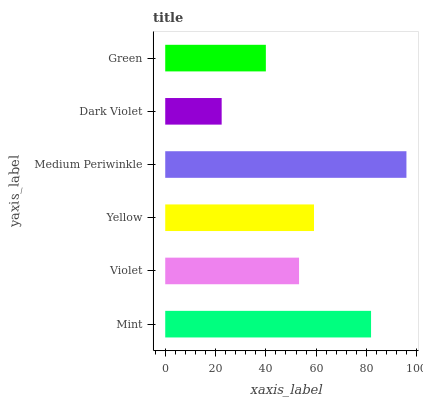Is Dark Violet the minimum?
Answer yes or no. Yes. Is Medium Periwinkle the maximum?
Answer yes or no. Yes. Is Violet the minimum?
Answer yes or no. No. Is Violet the maximum?
Answer yes or no. No. Is Mint greater than Violet?
Answer yes or no. Yes. Is Violet less than Mint?
Answer yes or no. Yes. Is Violet greater than Mint?
Answer yes or no. No. Is Mint less than Violet?
Answer yes or no. No. Is Yellow the high median?
Answer yes or no. Yes. Is Violet the low median?
Answer yes or no. Yes. Is Green the high median?
Answer yes or no. No. Is Medium Periwinkle the low median?
Answer yes or no. No. 